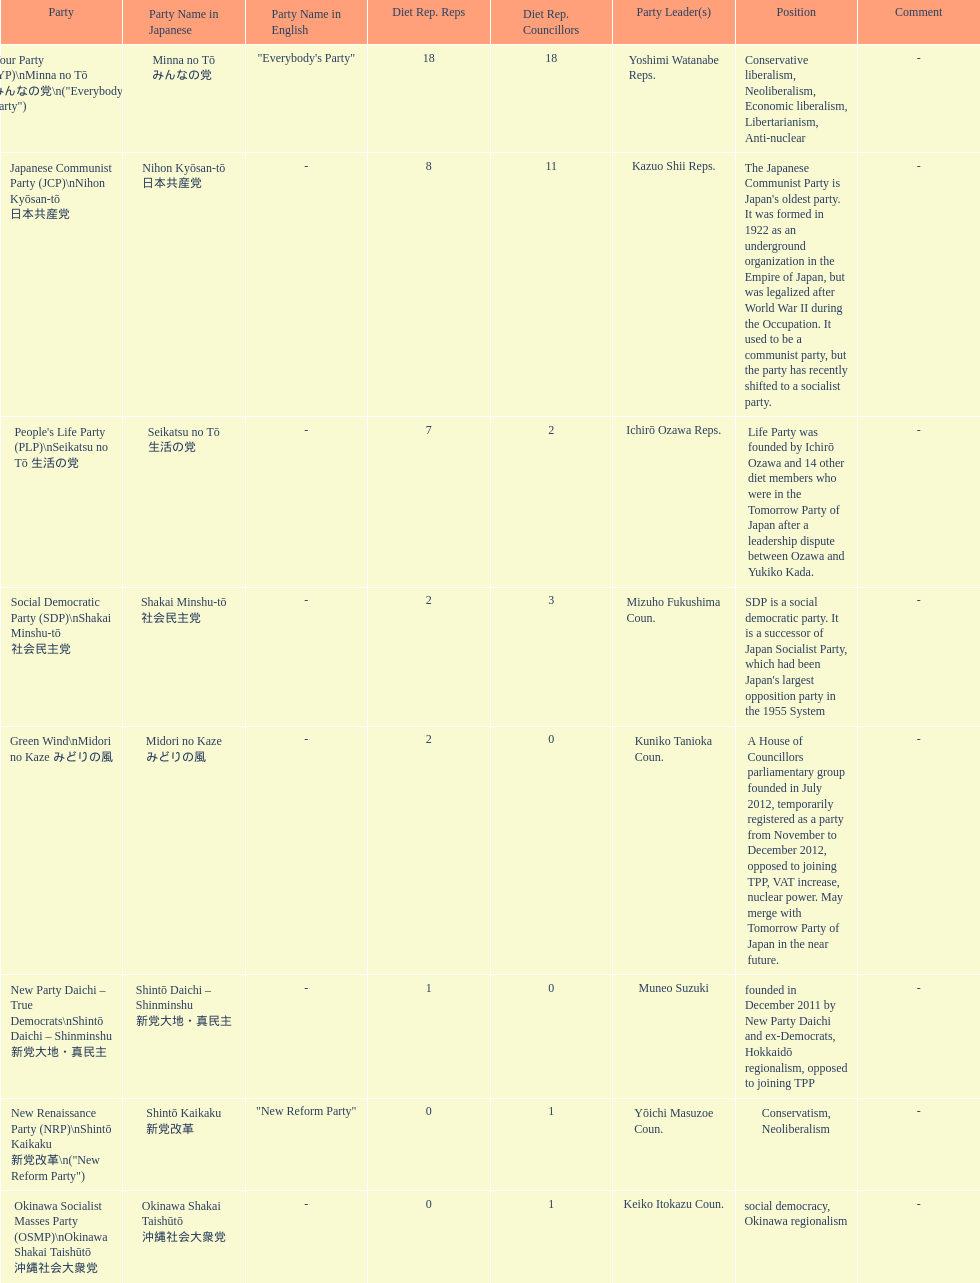How many representatives come from the green wind party? 2. 